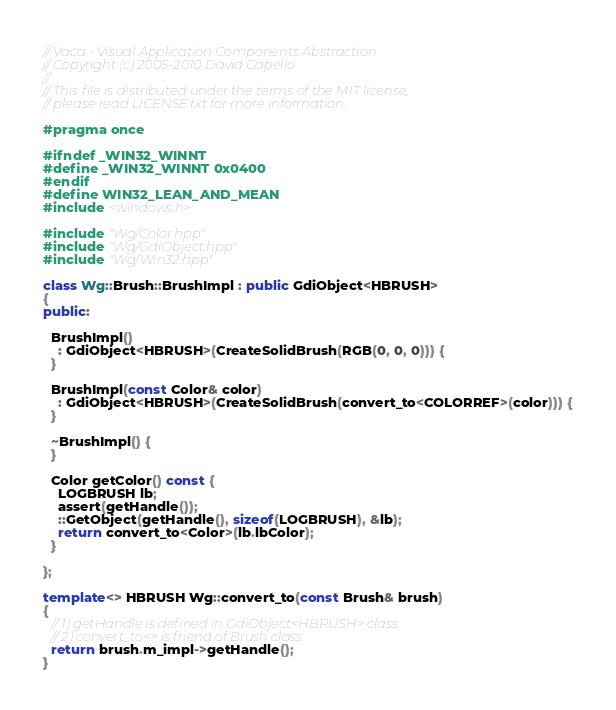<code> <loc_0><loc_0><loc_500><loc_500><_C++_>// Vaca - Visual Application Components Abstraction
// Copyright (c) 2005-2010 David Capello
//
// This file is distributed under the terms of the MIT license,
// please read LICENSE.txt for more information.

#pragma once

#ifndef _WIN32_WINNT
#define _WIN32_WINNT 0x0400
#endif
#define WIN32_LEAN_AND_MEAN
#include <windows.h>

#include "Wg/Color.hpp"
#include "Wg/GdiObject.hpp"
#include "Wg/Win32.hpp"

class Wg::Brush::BrushImpl : public GdiObject<HBRUSH>
{
public:

  BrushImpl()
    : GdiObject<HBRUSH>(CreateSolidBrush(RGB(0, 0, 0))) {
  }

  BrushImpl(const Color& color)
    : GdiObject<HBRUSH>(CreateSolidBrush(convert_to<COLORREF>(color))) {
  }

  ~BrushImpl() {
  }

  Color getColor() const {
    LOGBRUSH lb;
    assert(getHandle());
    ::GetObject(getHandle(), sizeof(LOGBRUSH), &lb);
    return convert_to<Color>(lb.lbColor);
  }

};

template<> HBRUSH Wg::convert_to(const Brush& brush)
{
  // 1) getHandle is defined in GdiObject<HBRUSH> class
  // 2) convert_to<> is friend of Brush class
  return brush.m_impl->getHandle();
}
</code> 